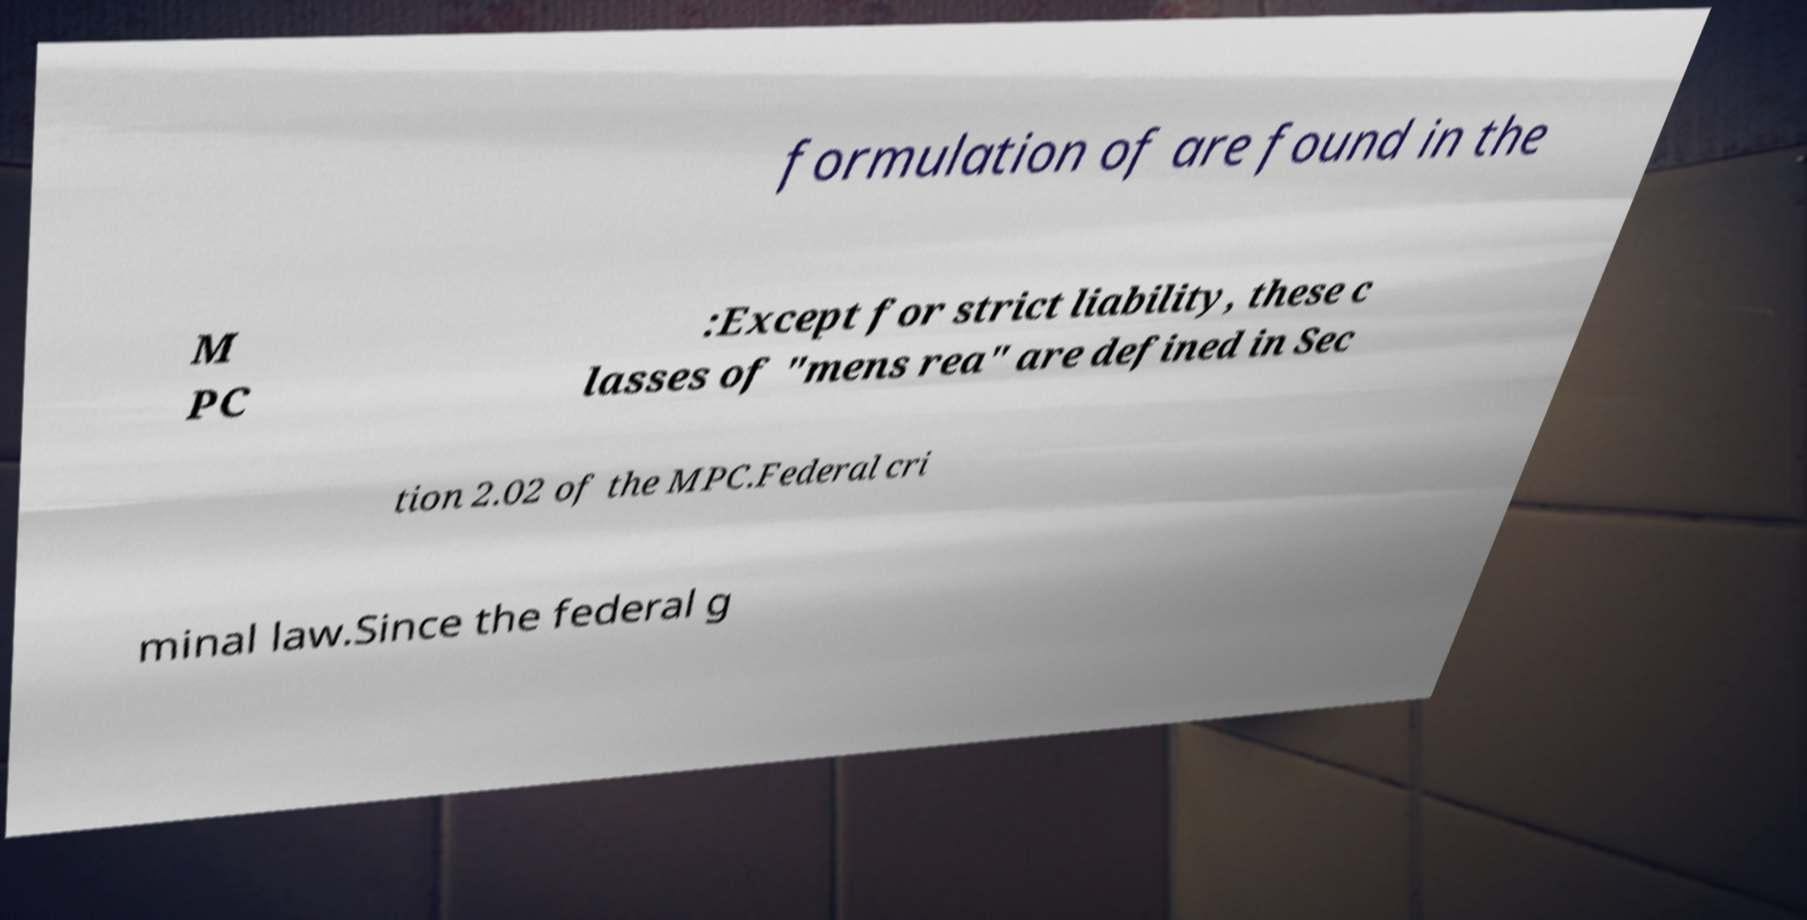What messages or text are displayed in this image? I need them in a readable, typed format. formulation of are found in the M PC :Except for strict liability, these c lasses of "mens rea" are defined in Sec tion 2.02 of the MPC.Federal cri minal law.Since the federal g 